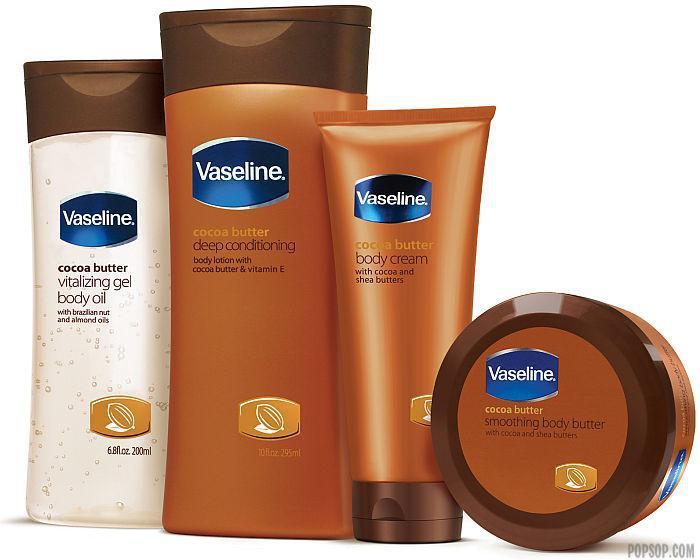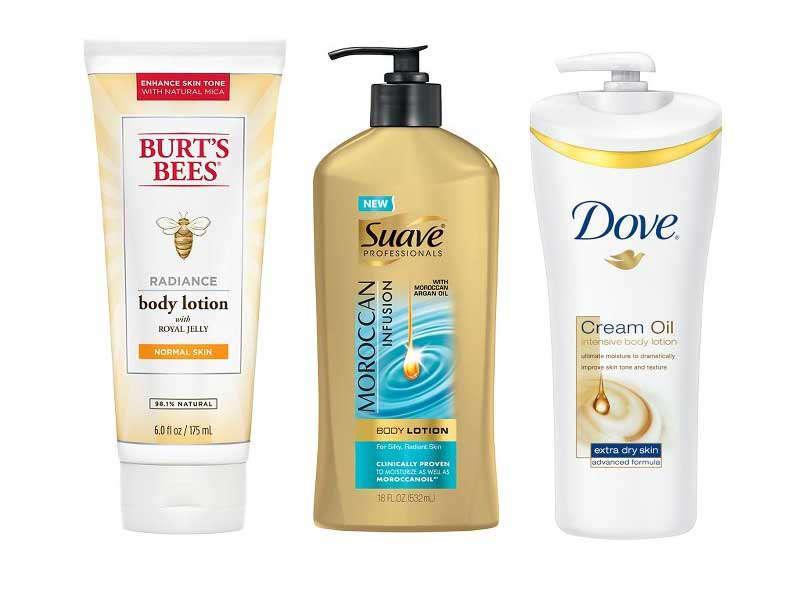The first image is the image on the left, the second image is the image on the right. For the images displayed, is the sentence "There are more items in the right image than in the left image." factually correct? Answer yes or no. No. 